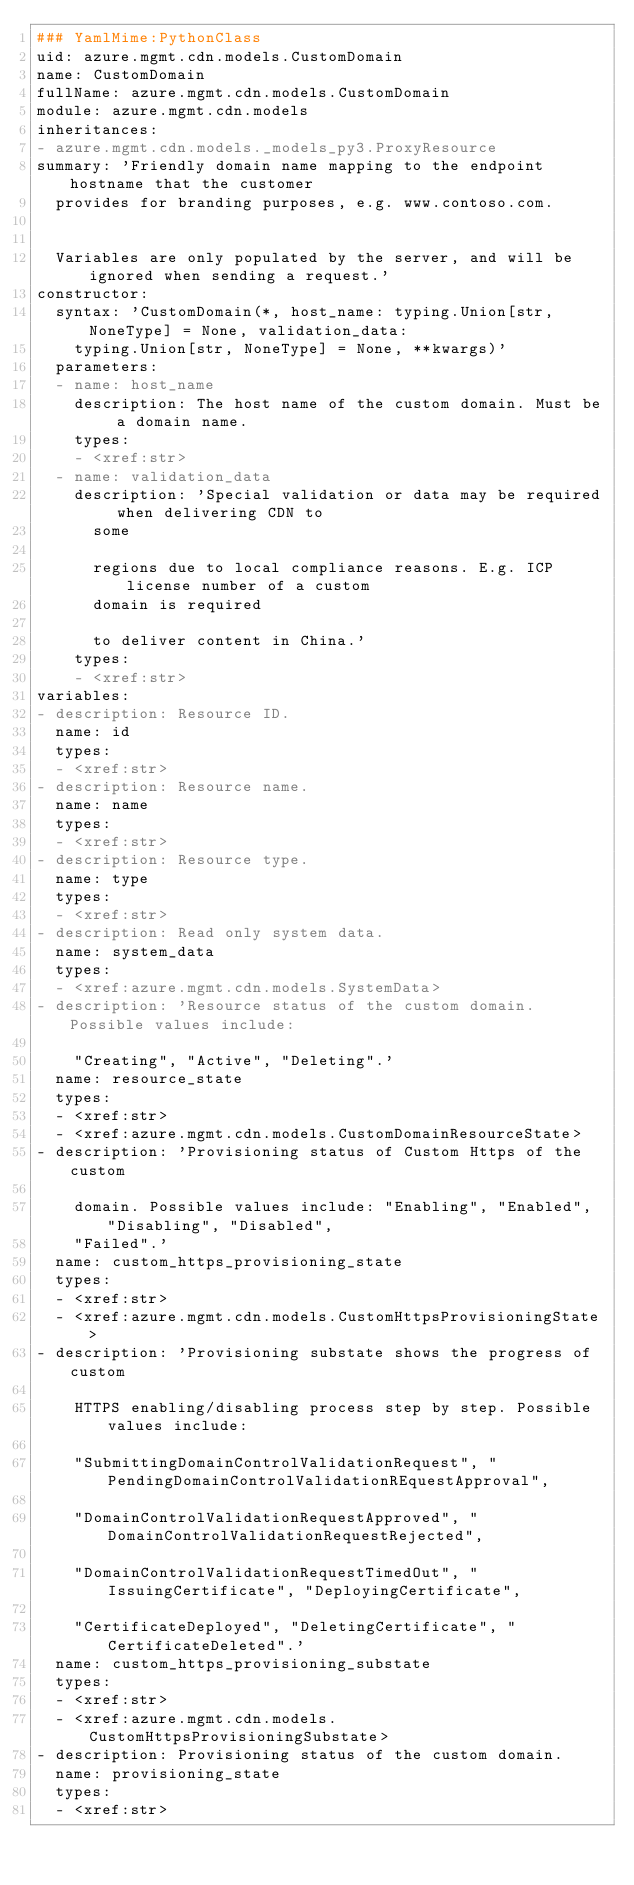<code> <loc_0><loc_0><loc_500><loc_500><_YAML_>### YamlMime:PythonClass
uid: azure.mgmt.cdn.models.CustomDomain
name: CustomDomain
fullName: azure.mgmt.cdn.models.CustomDomain
module: azure.mgmt.cdn.models
inheritances:
- azure.mgmt.cdn.models._models_py3.ProxyResource
summary: 'Friendly domain name mapping to the endpoint hostname that the customer
  provides for branding purposes, e.g. www.contoso.com.


  Variables are only populated by the server, and will be ignored when sending a request.'
constructor:
  syntax: 'CustomDomain(*, host_name: typing.Union[str, NoneType] = None, validation_data:
    typing.Union[str, NoneType] = None, **kwargs)'
  parameters:
  - name: host_name
    description: The host name of the custom domain. Must be a domain name.
    types:
    - <xref:str>
  - name: validation_data
    description: 'Special validation or data may be required when delivering CDN to
      some

      regions due to local compliance reasons. E.g. ICP license number of a custom
      domain is required

      to deliver content in China.'
    types:
    - <xref:str>
variables:
- description: Resource ID.
  name: id
  types:
  - <xref:str>
- description: Resource name.
  name: name
  types:
  - <xref:str>
- description: Resource type.
  name: type
  types:
  - <xref:str>
- description: Read only system data.
  name: system_data
  types:
  - <xref:azure.mgmt.cdn.models.SystemData>
- description: 'Resource status of the custom domain. Possible values include:

    "Creating", "Active", "Deleting".'
  name: resource_state
  types:
  - <xref:str>
  - <xref:azure.mgmt.cdn.models.CustomDomainResourceState>
- description: 'Provisioning status of Custom Https of the custom

    domain. Possible values include: "Enabling", "Enabled", "Disabling", "Disabled",
    "Failed".'
  name: custom_https_provisioning_state
  types:
  - <xref:str>
  - <xref:azure.mgmt.cdn.models.CustomHttpsProvisioningState>
- description: 'Provisioning substate shows the progress of custom

    HTTPS enabling/disabling process step by step. Possible values include:

    "SubmittingDomainControlValidationRequest", "PendingDomainControlValidationREquestApproval",

    "DomainControlValidationRequestApproved", "DomainControlValidationRequestRejected",

    "DomainControlValidationRequestTimedOut", "IssuingCertificate", "DeployingCertificate",

    "CertificateDeployed", "DeletingCertificate", "CertificateDeleted".'
  name: custom_https_provisioning_substate
  types:
  - <xref:str>
  - <xref:azure.mgmt.cdn.models.CustomHttpsProvisioningSubstate>
- description: Provisioning status of the custom domain.
  name: provisioning_state
  types:
  - <xref:str>
</code> 